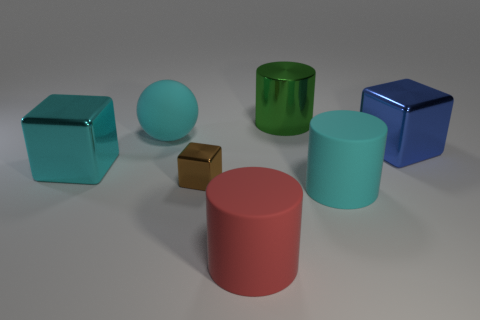What number of large cylinders are behind the object left of the rubber object that is on the left side of the small block?
Give a very brief answer. 1. Are there any blue objects to the left of the red cylinder?
Provide a short and direct response. No. How many cylinders have the same material as the big cyan block?
Your answer should be compact. 1. How many things are blue shiny things or big spheres?
Your answer should be very brief. 2. Are any gray matte spheres visible?
Offer a terse response. No. What is the thing to the left of the cyan matte thing that is to the left of the big cylinder on the right side of the big green metal object made of?
Give a very brief answer. Metal. Is the number of green metallic things in front of the brown metal object less than the number of big cubes?
Keep it short and to the point. Yes. There is a cyan block that is the same size as the cyan rubber ball; what is its material?
Provide a succinct answer. Metal. How big is the object that is both in front of the brown metallic block and behind the large red matte object?
Make the answer very short. Large. There is another rubber thing that is the same shape as the big red thing; what is its size?
Make the answer very short. Large. 